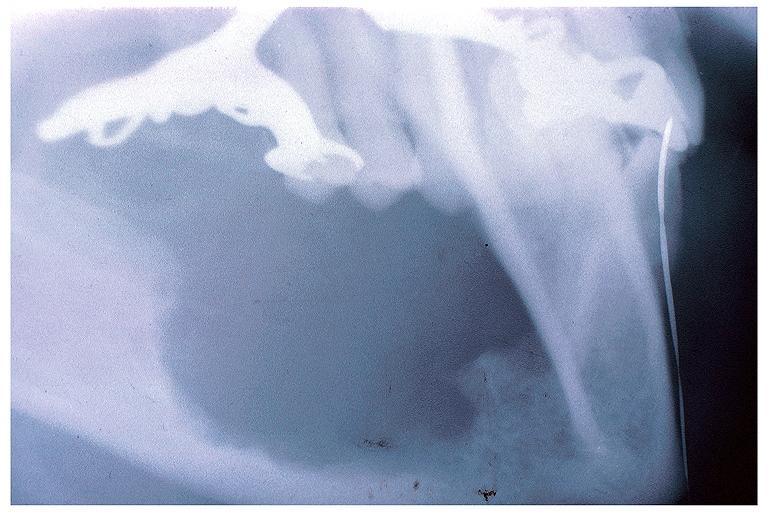s oral present?
Answer the question using a single word or phrase. Yes 